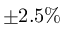Convert formula to latex. <formula><loc_0><loc_0><loc_500><loc_500>\pm 2 . 5 \%</formula> 